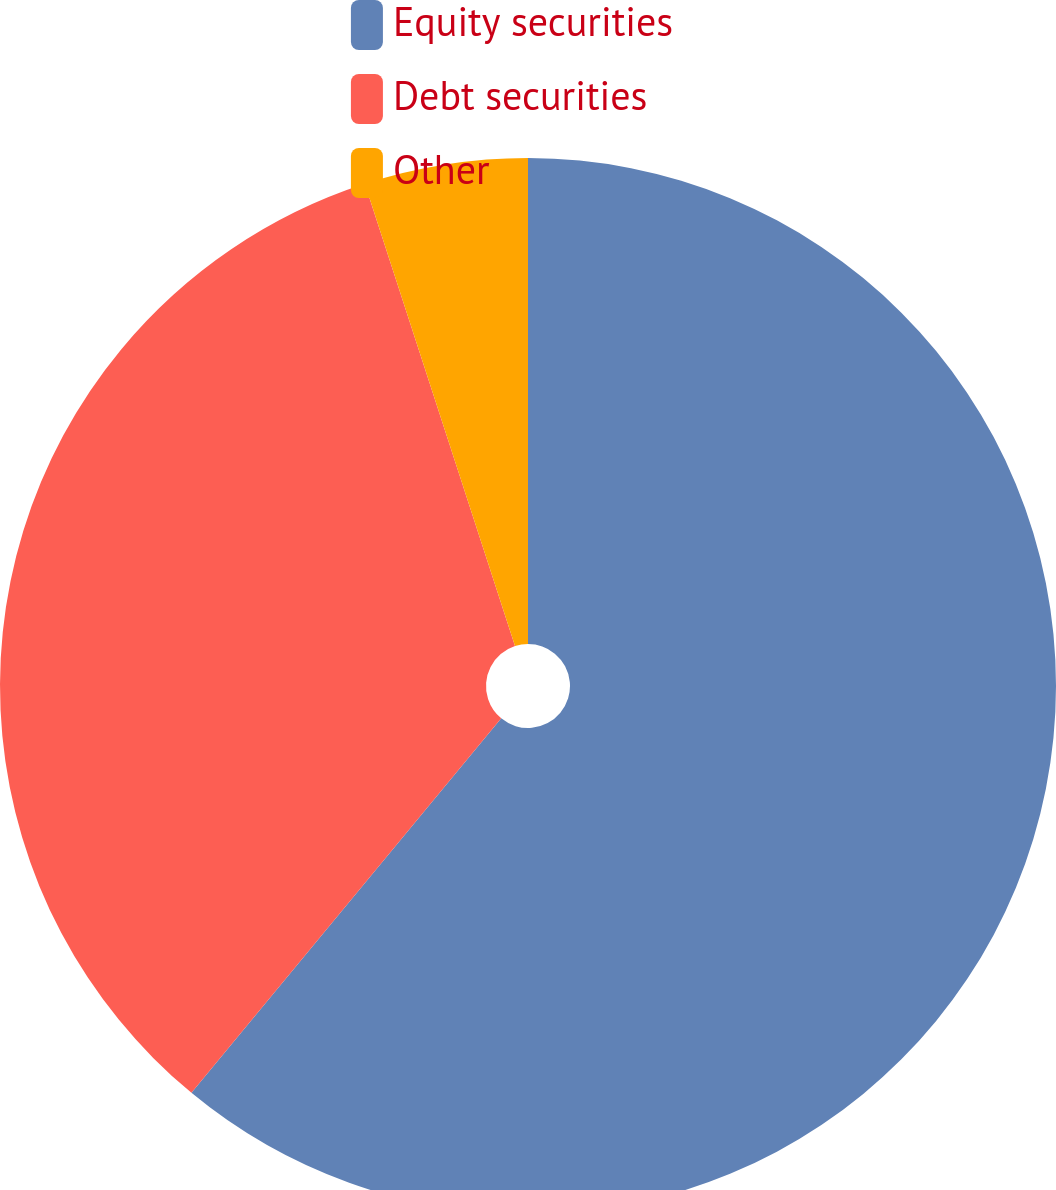Convert chart. <chart><loc_0><loc_0><loc_500><loc_500><pie_chart><fcel>Equity securities<fcel>Debt securities<fcel>Other<nl><fcel>61.0%<fcel>34.0%<fcel>5.0%<nl></chart> 